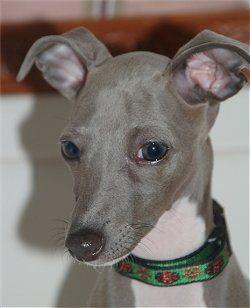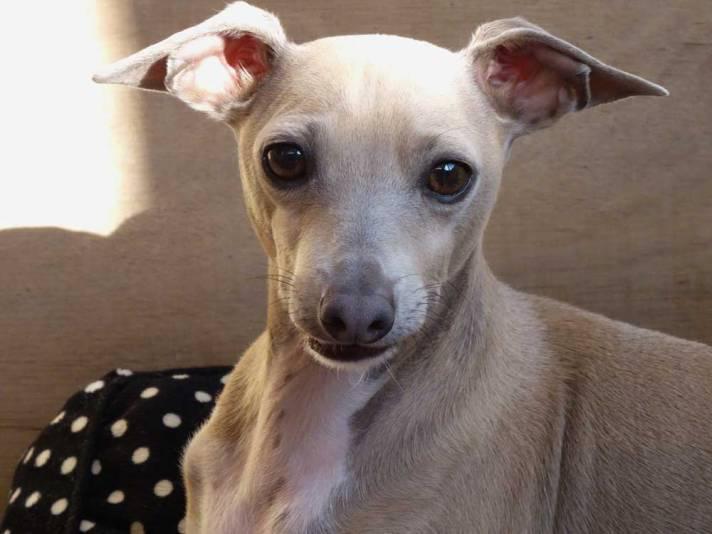The first image is the image on the left, the second image is the image on the right. Analyze the images presented: Is the assertion "There is a collar around the neck of at least one dog in the image on the right." valid? Answer yes or no. No. The first image is the image on the left, the second image is the image on the right. Given the left and right images, does the statement "The combined images include a hound wearing a pink collar and the images include an item of apparel worn by a dog that is not a collar." hold true? Answer yes or no. No. 